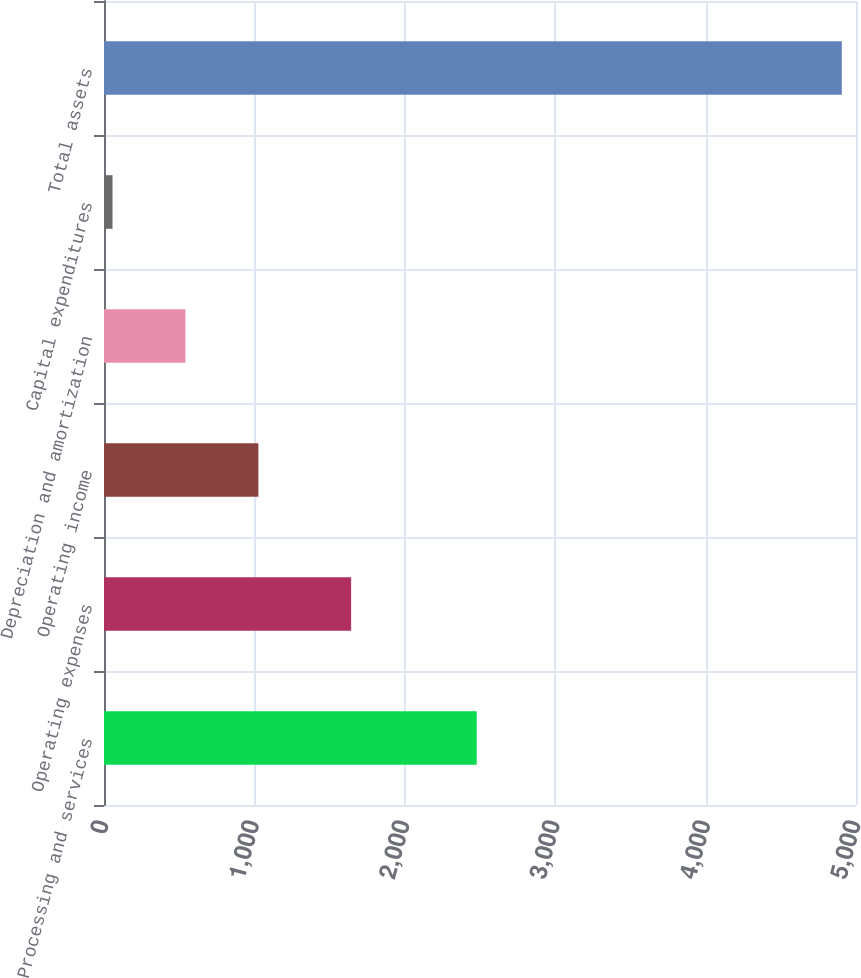Convert chart. <chart><loc_0><loc_0><loc_500><loc_500><bar_chart><fcel>Processing and services<fcel>Operating expenses<fcel>Operating income<fcel>Depreciation and amortization<fcel>Capital expenditures<fcel>Total assets<nl><fcel>2478.1<fcel>1643.1<fcel>1026.42<fcel>541.51<fcel>56.6<fcel>4905.7<nl></chart> 